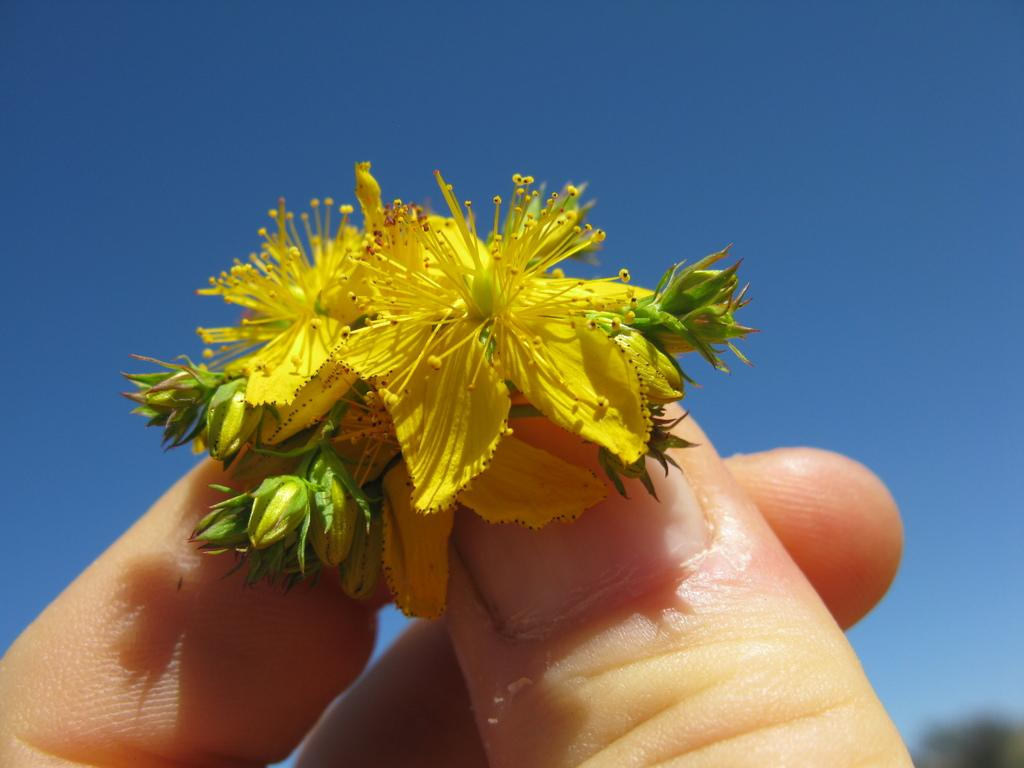What is the person in the image holding? The person is holding flowers in the image. What color are the flowers? The flowers are yellow. What can be seen in the background of the image? The blue sky is visible in the background of the image. Is there any milk being poured into a jar in the image? No, there is no milk or jar present in the image. Can you see any steam coming from the flowers in the image? No, there is no steam present in the image. 